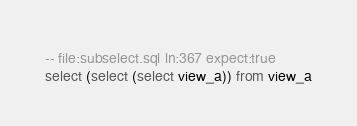Convert code to text. <code><loc_0><loc_0><loc_500><loc_500><_SQL_>-- file:subselect.sql ln:367 expect:true
select (select (select view_a)) from view_a
</code> 